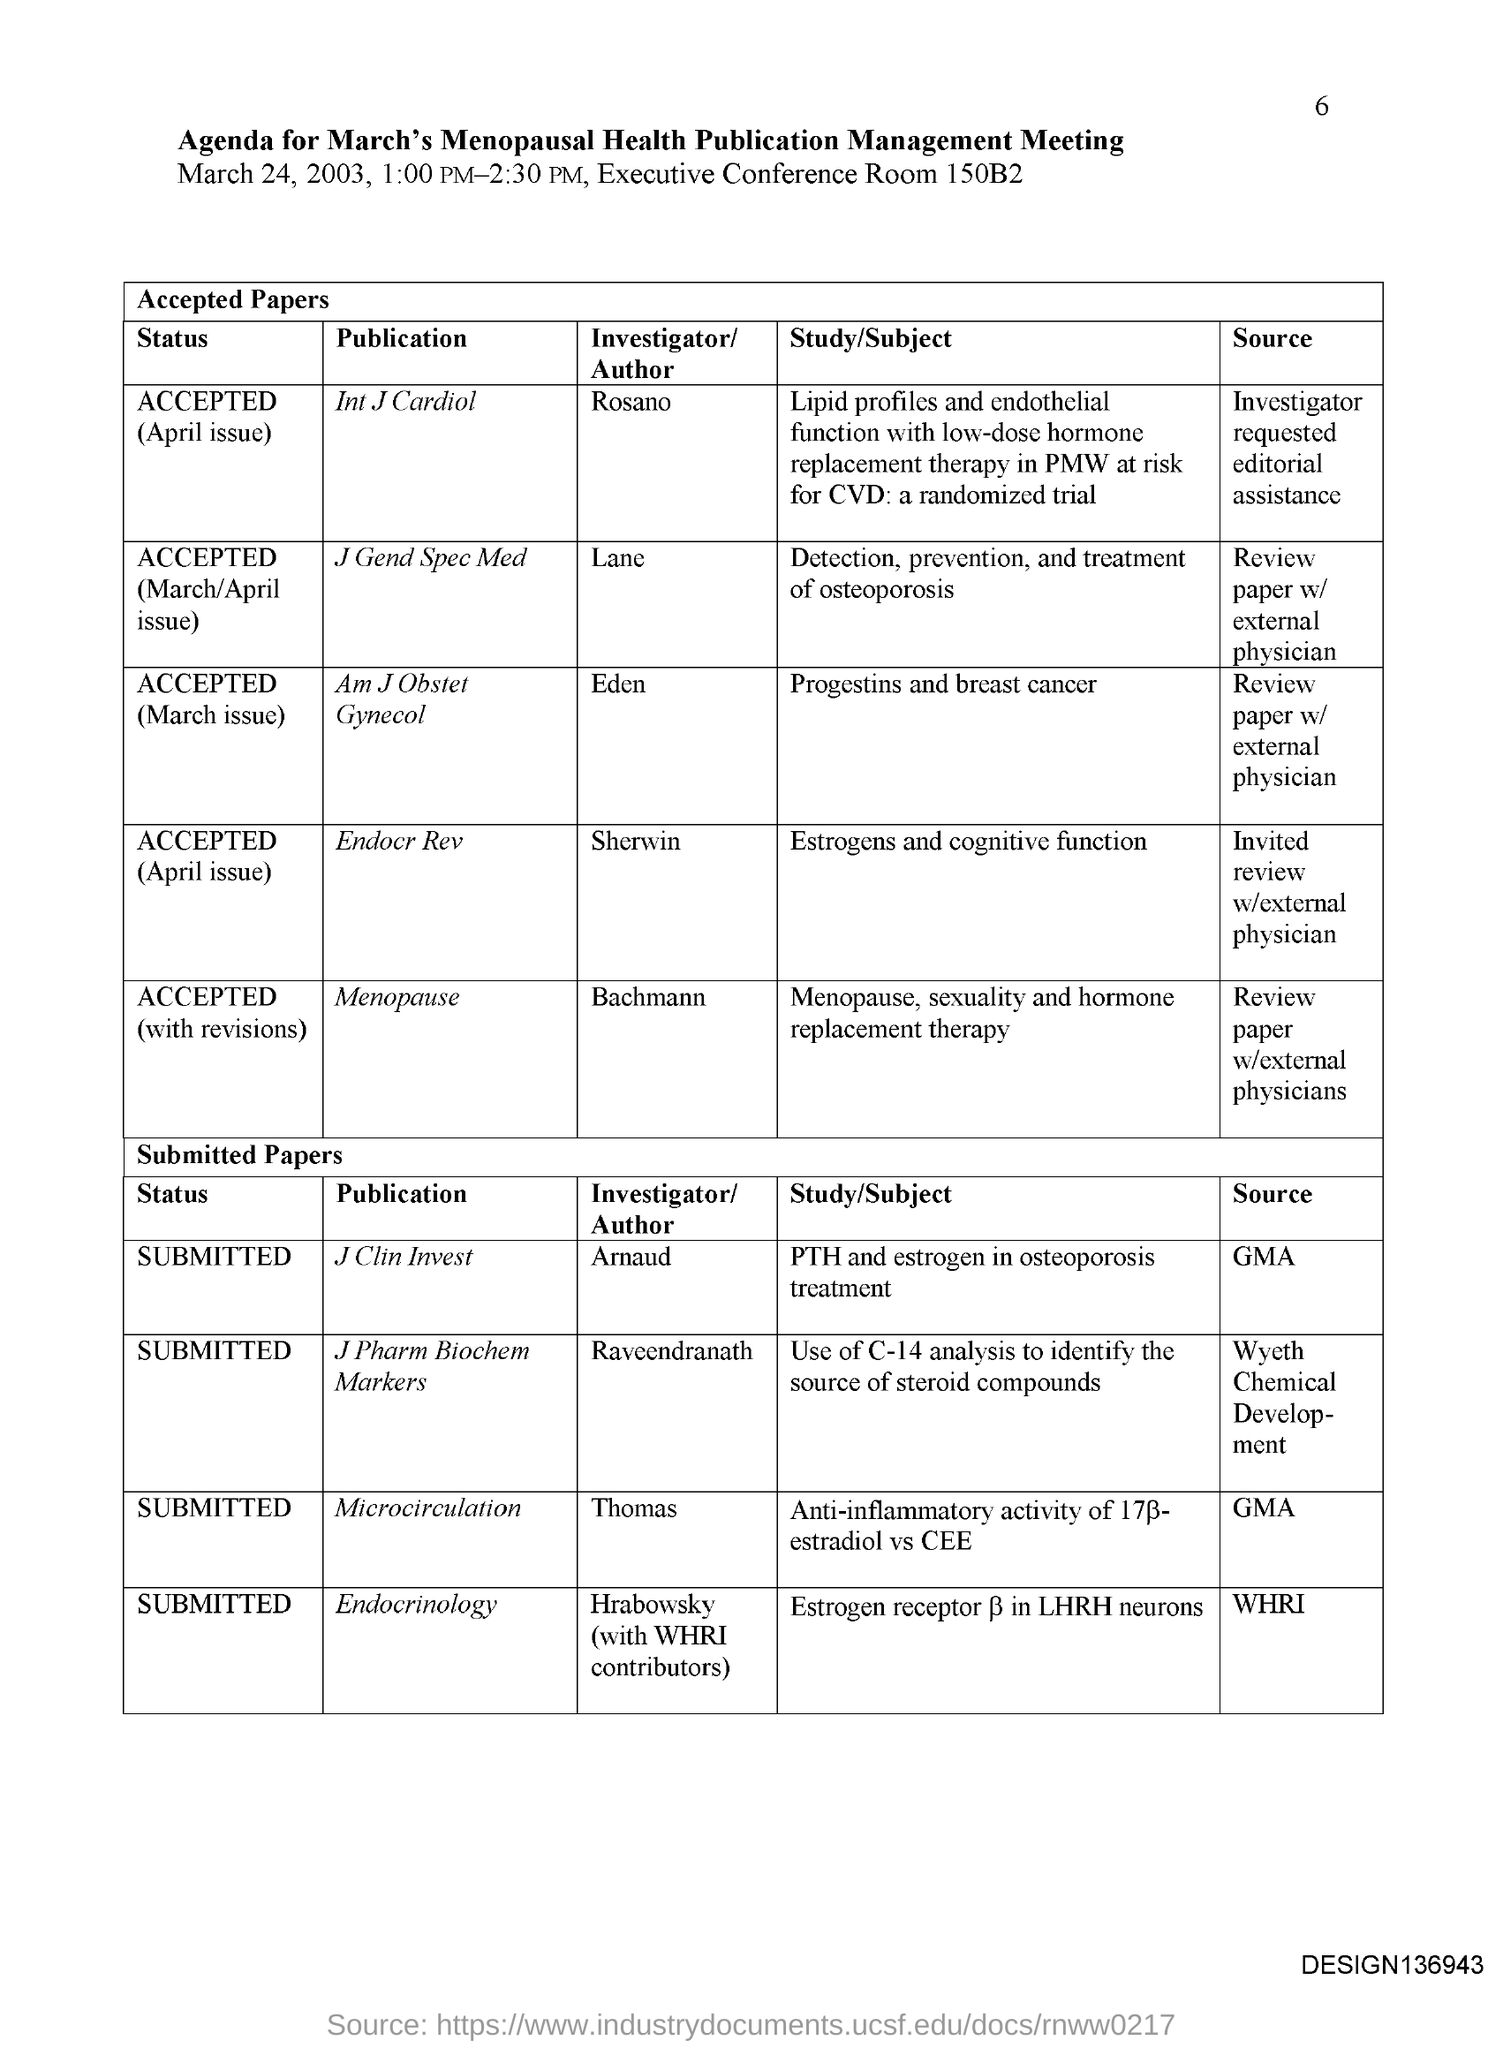What is the Page Number?
Provide a short and direct response. 6. What is the title of the document?
Your answer should be very brief. Agenda for March's Menopausal Health Publication Management Meeting. Who is the author of the publication "Menopause"?
Your answer should be very brief. Bachmann. Sherwin is the author of which publication?
Keep it short and to the point. Endocr Rev. Thomas is the author of which publication?
Keep it short and to the point. Microcirculation. What is the status of the publication "Microcirculation"?
Give a very brief answer. Submitted. Who is the author of the publication "J Clin Invest"?
Offer a very short reply. Arnaud. Who is the author of the publication "J Gend Spec Med"?
Give a very brief answer. Lane. What is the status of the publication "Endocrinology"?
Offer a very short reply. Submitted. What is the status of the publication "J Clin Invest"?
Your answer should be very brief. SUBMITTED. 